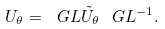Convert formula to latex. <formula><loc_0><loc_0><loc_500><loc_500>U _ { \theta } = \ G L \tilde { U } _ { \theta } \ G L ^ { - 1 } .</formula> 